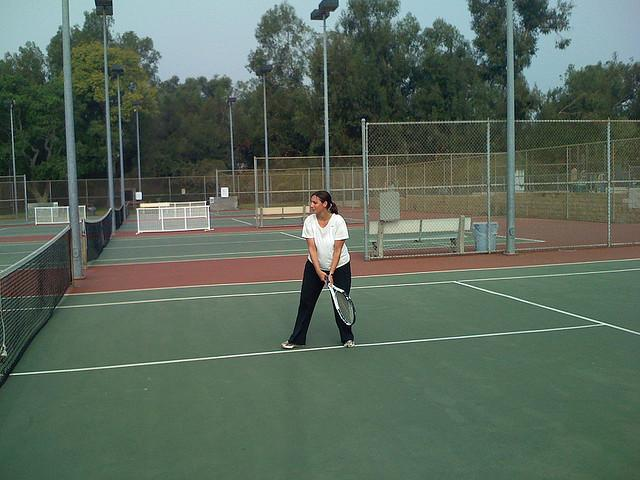What are the tall silver poles used for?

Choices:
A) targets
B) swinging
C) climbing
D) lighting lighting 